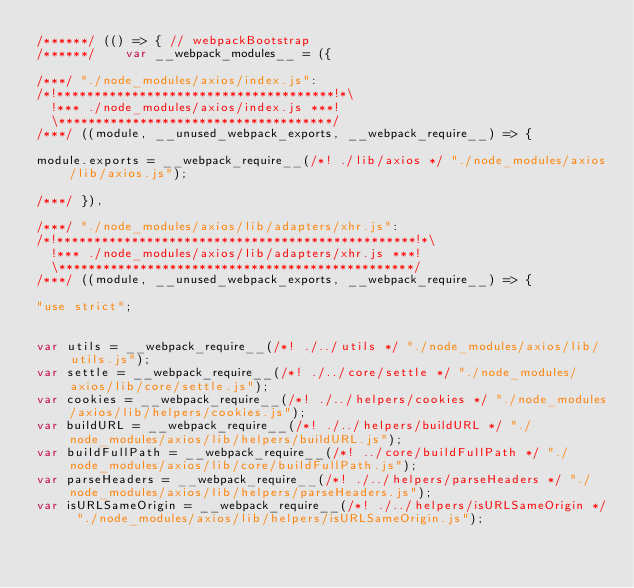Convert code to text. <code><loc_0><loc_0><loc_500><loc_500><_JavaScript_>/******/ (() => { // webpackBootstrap
/******/ 	var __webpack_modules__ = ({

/***/ "./node_modules/axios/index.js":
/*!*************************************!*\
  !*** ./node_modules/axios/index.js ***!
  \*************************************/
/***/ ((module, __unused_webpack_exports, __webpack_require__) => {

module.exports = __webpack_require__(/*! ./lib/axios */ "./node_modules/axios/lib/axios.js");

/***/ }),

/***/ "./node_modules/axios/lib/adapters/xhr.js":
/*!************************************************!*\
  !*** ./node_modules/axios/lib/adapters/xhr.js ***!
  \************************************************/
/***/ ((module, __unused_webpack_exports, __webpack_require__) => {

"use strict";


var utils = __webpack_require__(/*! ./../utils */ "./node_modules/axios/lib/utils.js");
var settle = __webpack_require__(/*! ./../core/settle */ "./node_modules/axios/lib/core/settle.js");
var cookies = __webpack_require__(/*! ./../helpers/cookies */ "./node_modules/axios/lib/helpers/cookies.js");
var buildURL = __webpack_require__(/*! ./../helpers/buildURL */ "./node_modules/axios/lib/helpers/buildURL.js");
var buildFullPath = __webpack_require__(/*! ../core/buildFullPath */ "./node_modules/axios/lib/core/buildFullPath.js");
var parseHeaders = __webpack_require__(/*! ./../helpers/parseHeaders */ "./node_modules/axios/lib/helpers/parseHeaders.js");
var isURLSameOrigin = __webpack_require__(/*! ./../helpers/isURLSameOrigin */ "./node_modules/axios/lib/helpers/isURLSameOrigin.js");</code> 